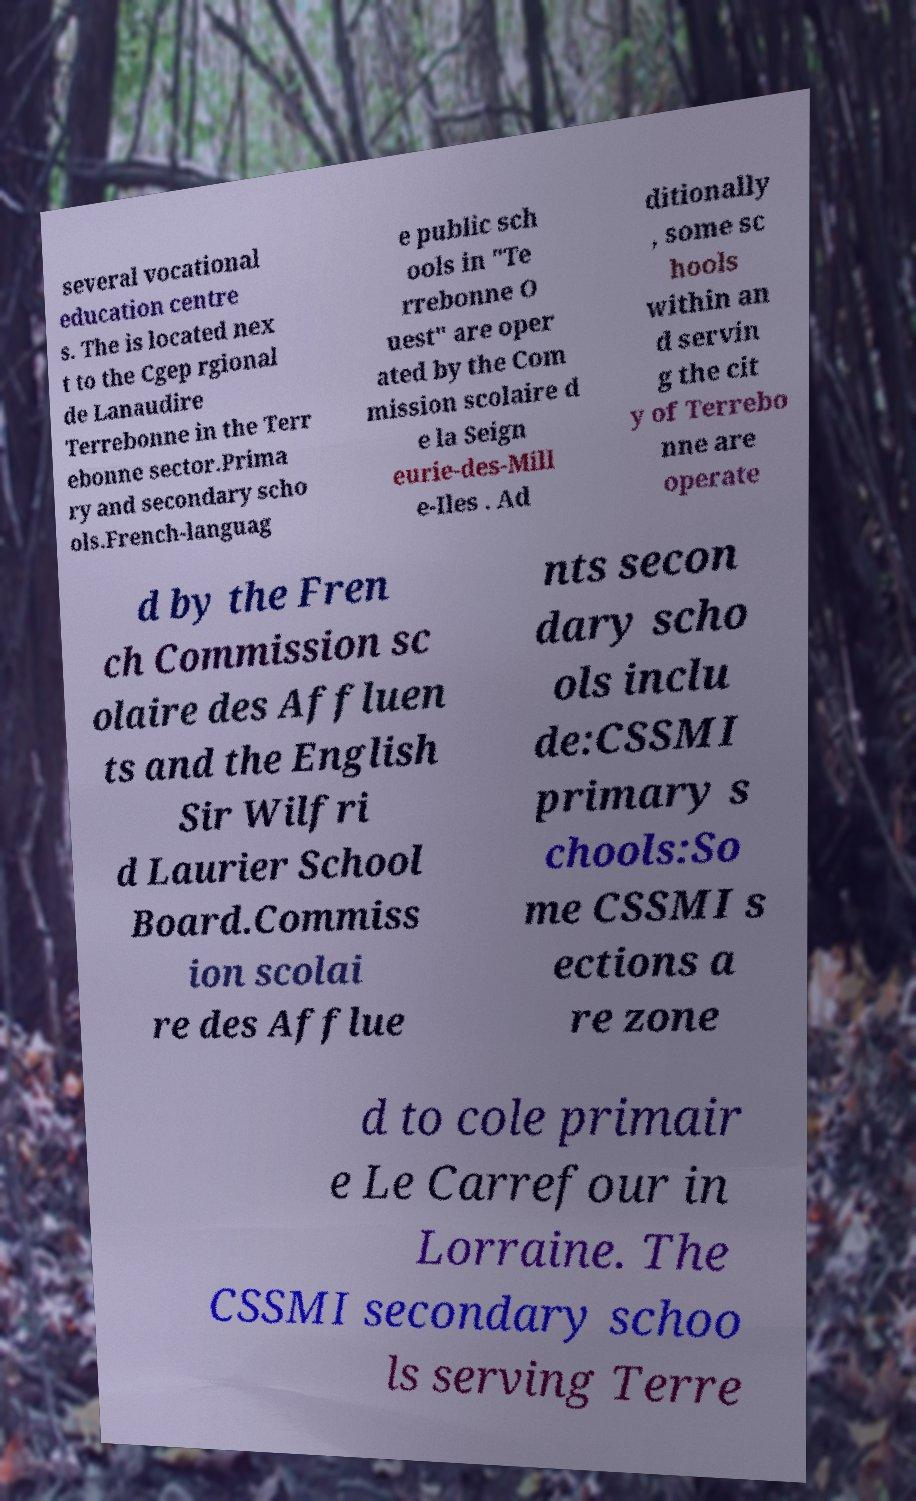Could you assist in decoding the text presented in this image and type it out clearly? several vocational education centre s. The is located nex t to the Cgep rgional de Lanaudire Terrebonne in the Terr ebonne sector.Prima ry and secondary scho ols.French-languag e public sch ools in "Te rrebonne O uest" are oper ated by the Com mission scolaire d e la Seign eurie-des-Mill e-Iles . Ad ditionally , some sc hools within an d servin g the cit y of Terrebo nne are operate d by the Fren ch Commission sc olaire des Affluen ts and the English Sir Wilfri d Laurier School Board.Commiss ion scolai re des Afflue nts secon dary scho ols inclu de:CSSMI primary s chools:So me CSSMI s ections a re zone d to cole primair e Le Carrefour in Lorraine. The CSSMI secondary schoo ls serving Terre 